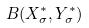Convert formula to latex. <formula><loc_0><loc_0><loc_500><loc_500>B ( X _ { \sigma } ^ { * } , Y _ { \sigma } ^ { * } )</formula> 